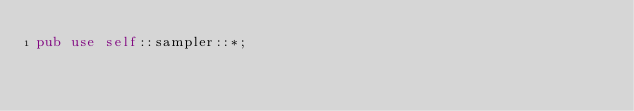Convert code to text. <code><loc_0><loc_0><loc_500><loc_500><_Rust_>pub use self::sampler::*;
</code> 